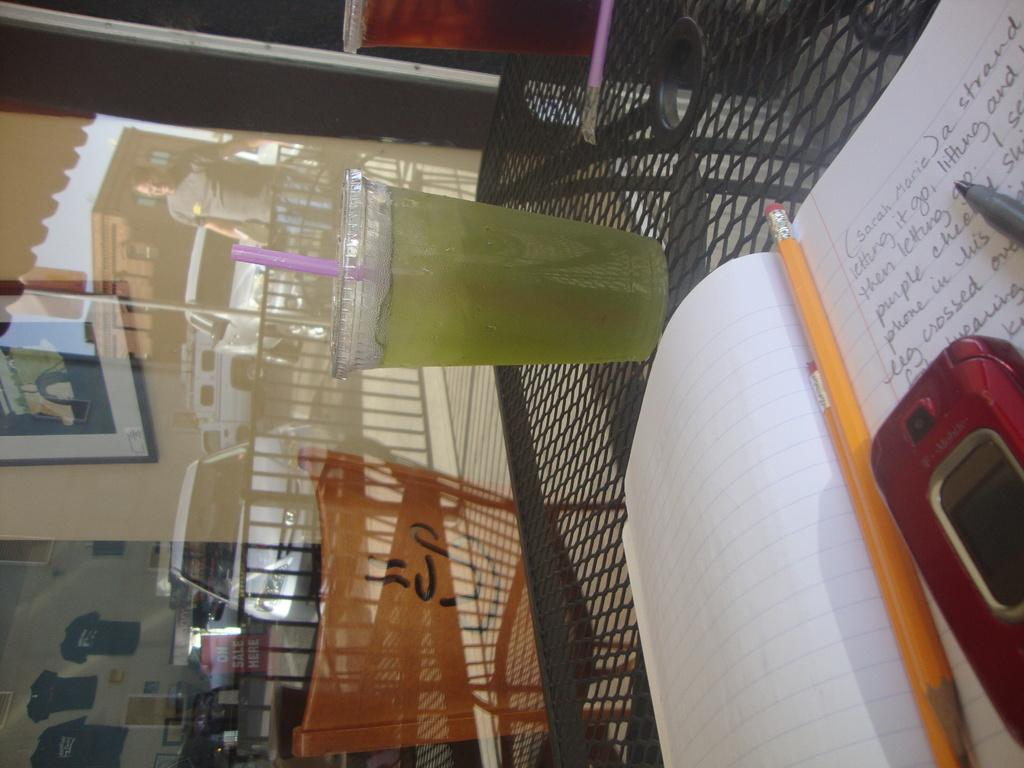<image>
Summarize the visual content of the image. a notepad sits on the table with the words sarah marie written on it 